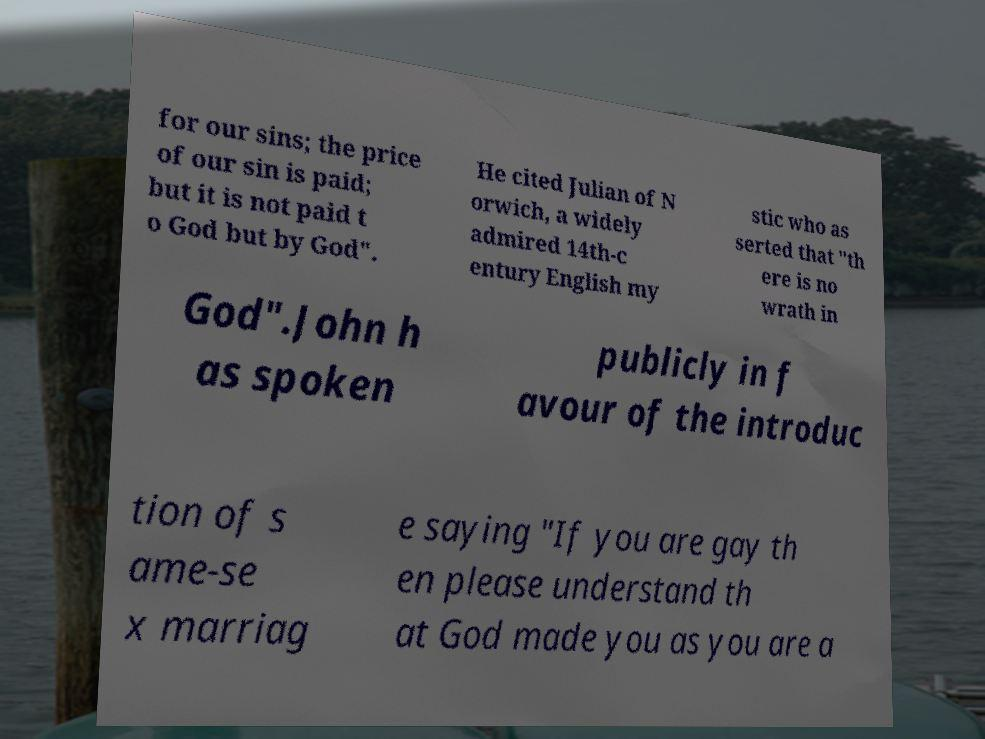Could you assist in decoding the text presented in this image and type it out clearly? for our sins; the price of our sin is paid; but it is not paid t o God but by God". He cited Julian of N orwich, a widely admired 14th-c entury English my stic who as serted that "th ere is no wrath in God".John h as spoken publicly in f avour of the introduc tion of s ame-se x marriag e saying "If you are gay th en please understand th at God made you as you are a 